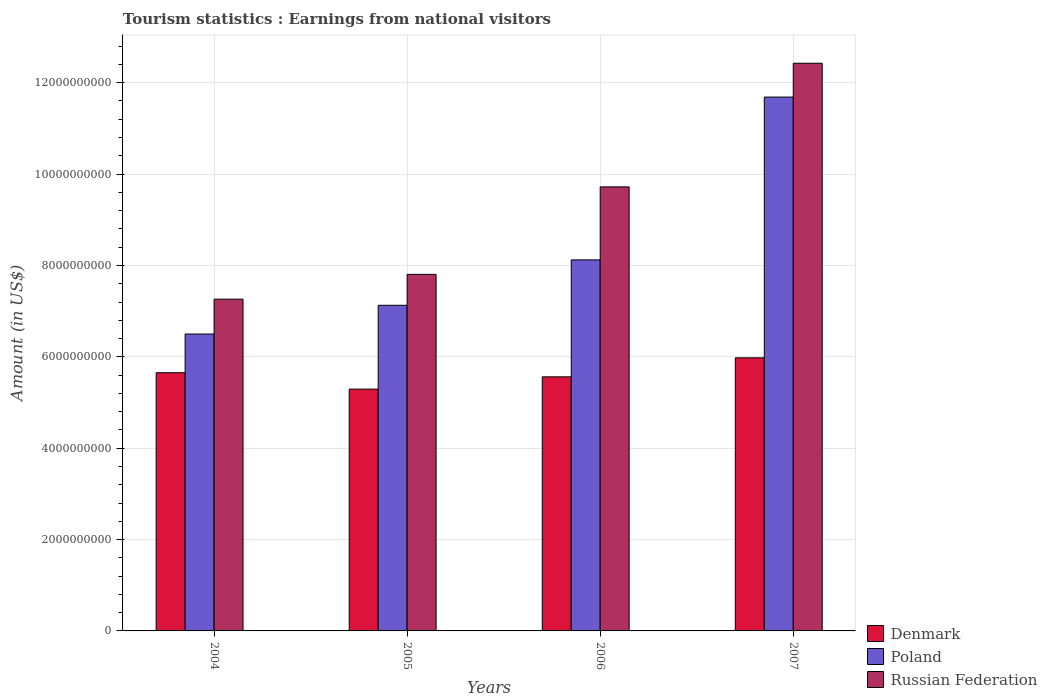How many different coloured bars are there?
Make the answer very short. 3. How many groups of bars are there?
Your answer should be compact. 4. Are the number of bars per tick equal to the number of legend labels?
Keep it short and to the point. Yes. Are the number of bars on each tick of the X-axis equal?
Give a very brief answer. Yes. How many bars are there on the 2nd tick from the right?
Offer a terse response. 3. In how many cases, is the number of bars for a given year not equal to the number of legend labels?
Make the answer very short. 0. What is the earnings from national visitors in Denmark in 2004?
Your response must be concise. 5.65e+09. Across all years, what is the maximum earnings from national visitors in Poland?
Provide a succinct answer. 1.17e+1. Across all years, what is the minimum earnings from national visitors in Poland?
Give a very brief answer. 6.50e+09. In which year was the earnings from national visitors in Denmark maximum?
Provide a succinct answer. 2007. What is the total earnings from national visitors in Denmark in the graph?
Your answer should be compact. 2.25e+1. What is the difference between the earnings from national visitors in Denmark in 2006 and that in 2007?
Give a very brief answer. -4.16e+08. What is the difference between the earnings from national visitors in Russian Federation in 2005 and the earnings from national visitors in Poland in 2004?
Your response must be concise. 1.31e+09. What is the average earnings from national visitors in Denmark per year?
Your response must be concise. 5.62e+09. In the year 2005, what is the difference between the earnings from national visitors in Poland and earnings from national visitors in Russian Federation?
Ensure brevity in your answer.  -6.77e+08. What is the ratio of the earnings from national visitors in Denmark in 2005 to that in 2006?
Give a very brief answer. 0.95. Is the earnings from national visitors in Denmark in 2006 less than that in 2007?
Ensure brevity in your answer.  Yes. Is the difference between the earnings from national visitors in Poland in 2004 and 2005 greater than the difference between the earnings from national visitors in Russian Federation in 2004 and 2005?
Provide a succinct answer. No. What is the difference between the highest and the second highest earnings from national visitors in Poland?
Ensure brevity in your answer.  3.56e+09. What is the difference between the highest and the lowest earnings from national visitors in Poland?
Your answer should be compact. 5.19e+09. What does the 2nd bar from the right in 2006 represents?
Your answer should be compact. Poland. Are all the bars in the graph horizontal?
Provide a short and direct response. No. How many years are there in the graph?
Your answer should be compact. 4. What is the difference between two consecutive major ticks on the Y-axis?
Offer a very short reply. 2.00e+09. Are the values on the major ticks of Y-axis written in scientific E-notation?
Your response must be concise. No. Does the graph contain any zero values?
Ensure brevity in your answer.  No. Does the graph contain grids?
Give a very brief answer. Yes. Where does the legend appear in the graph?
Keep it short and to the point. Bottom right. How many legend labels are there?
Offer a terse response. 3. What is the title of the graph?
Ensure brevity in your answer.  Tourism statistics : Earnings from national visitors. What is the Amount (in US$) of Denmark in 2004?
Offer a very short reply. 5.65e+09. What is the Amount (in US$) of Poland in 2004?
Your response must be concise. 6.50e+09. What is the Amount (in US$) in Russian Federation in 2004?
Provide a succinct answer. 7.26e+09. What is the Amount (in US$) of Denmark in 2005?
Your answer should be compact. 5.29e+09. What is the Amount (in US$) in Poland in 2005?
Your response must be concise. 7.13e+09. What is the Amount (in US$) in Russian Federation in 2005?
Ensure brevity in your answer.  7.80e+09. What is the Amount (in US$) in Denmark in 2006?
Provide a short and direct response. 5.56e+09. What is the Amount (in US$) in Poland in 2006?
Give a very brief answer. 8.12e+09. What is the Amount (in US$) in Russian Federation in 2006?
Make the answer very short. 9.72e+09. What is the Amount (in US$) in Denmark in 2007?
Keep it short and to the point. 5.98e+09. What is the Amount (in US$) of Poland in 2007?
Offer a very short reply. 1.17e+1. What is the Amount (in US$) of Russian Federation in 2007?
Your answer should be very brief. 1.24e+1. Across all years, what is the maximum Amount (in US$) in Denmark?
Ensure brevity in your answer.  5.98e+09. Across all years, what is the maximum Amount (in US$) of Poland?
Your response must be concise. 1.17e+1. Across all years, what is the maximum Amount (in US$) in Russian Federation?
Provide a short and direct response. 1.24e+1. Across all years, what is the minimum Amount (in US$) of Denmark?
Provide a succinct answer. 5.29e+09. Across all years, what is the minimum Amount (in US$) of Poland?
Provide a short and direct response. 6.50e+09. Across all years, what is the minimum Amount (in US$) in Russian Federation?
Give a very brief answer. 7.26e+09. What is the total Amount (in US$) of Denmark in the graph?
Keep it short and to the point. 2.25e+1. What is the total Amount (in US$) in Poland in the graph?
Make the answer very short. 3.34e+1. What is the total Amount (in US$) of Russian Federation in the graph?
Your response must be concise. 3.72e+1. What is the difference between the Amount (in US$) of Denmark in 2004 and that in 2005?
Your answer should be compact. 3.59e+08. What is the difference between the Amount (in US$) of Poland in 2004 and that in 2005?
Provide a short and direct response. -6.29e+08. What is the difference between the Amount (in US$) in Russian Federation in 2004 and that in 2005?
Offer a very short reply. -5.43e+08. What is the difference between the Amount (in US$) in Denmark in 2004 and that in 2006?
Keep it short and to the point. 9.00e+07. What is the difference between the Amount (in US$) in Poland in 2004 and that in 2006?
Keep it short and to the point. -1.62e+09. What is the difference between the Amount (in US$) in Russian Federation in 2004 and that in 2006?
Your answer should be very brief. -2.46e+09. What is the difference between the Amount (in US$) in Denmark in 2004 and that in 2007?
Give a very brief answer. -3.26e+08. What is the difference between the Amount (in US$) in Poland in 2004 and that in 2007?
Provide a short and direct response. -5.19e+09. What is the difference between the Amount (in US$) in Russian Federation in 2004 and that in 2007?
Provide a succinct answer. -5.16e+09. What is the difference between the Amount (in US$) in Denmark in 2005 and that in 2006?
Make the answer very short. -2.69e+08. What is the difference between the Amount (in US$) of Poland in 2005 and that in 2006?
Keep it short and to the point. -9.94e+08. What is the difference between the Amount (in US$) in Russian Federation in 2005 and that in 2006?
Your response must be concise. -1.92e+09. What is the difference between the Amount (in US$) in Denmark in 2005 and that in 2007?
Your answer should be compact. -6.85e+08. What is the difference between the Amount (in US$) in Poland in 2005 and that in 2007?
Your answer should be very brief. -4.56e+09. What is the difference between the Amount (in US$) of Russian Federation in 2005 and that in 2007?
Ensure brevity in your answer.  -4.62e+09. What is the difference between the Amount (in US$) of Denmark in 2006 and that in 2007?
Make the answer very short. -4.16e+08. What is the difference between the Amount (in US$) in Poland in 2006 and that in 2007?
Your answer should be very brief. -3.56e+09. What is the difference between the Amount (in US$) of Russian Federation in 2006 and that in 2007?
Your response must be concise. -2.71e+09. What is the difference between the Amount (in US$) in Denmark in 2004 and the Amount (in US$) in Poland in 2005?
Make the answer very short. -1.48e+09. What is the difference between the Amount (in US$) of Denmark in 2004 and the Amount (in US$) of Russian Federation in 2005?
Your answer should be compact. -2.15e+09. What is the difference between the Amount (in US$) in Poland in 2004 and the Amount (in US$) in Russian Federation in 2005?
Provide a short and direct response. -1.31e+09. What is the difference between the Amount (in US$) in Denmark in 2004 and the Amount (in US$) in Poland in 2006?
Your answer should be very brief. -2.47e+09. What is the difference between the Amount (in US$) in Denmark in 2004 and the Amount (in US$) in Russian Federation in 2006?
Your answer should be very brief. -4.07e+09. What is the difference between the Amount (in US$) in Poland in 2004 and the Amount (in US$) in Russian Federation in 2006?
Provide a succinct answer. -3.22e+09. What is the difference between the Amount (in US$) in Denmark in 2004 and the Amount (in US$) in Poland in 2007?
Keep it short and to the point. -6.03e+09. What is the difference between the Amount (in US$) in Denmark in 2004 and the Amount (in US$) in Russian Federation in 2007?
Your answer should be compact. -6.77e+09. What is the difference between the Amount (in US$) in Poland in 2004 and the Amount (in US$) in Russian Federation in 2007?
Keep it short and to the point. -5.93e+09. What is the difference between the Amount (in US$) in Denmark in 2005 and the Amount (in US$) in Poland in 2006?
Make the answer very short. -2.83e+09. What is the difference between the Amount (in US$) in Denmark in 2005 and the Amount (in US$) in Russian Federation in 2006?
Offer a terse response. -4.43e+09. What is the difference between the Amount (in US$) in Poland in 2005 and the Amount (in US$) in Russian Federation in 2006?
Your answer should be compact. -2.59e+09. What is the difference between the Amount (in US$) of Denmark in 2005 and the Amount (in US$) of Poland in 2007?
Your answer should be compact. -6.39e+09. What is the difference between the Amount (in US$) of Denmark in 2005 and the Amount (in US$) of Russian Federation in 2007?
Make the answer very short. -7.13e+09. What is the difference between the Amount (in US$) of Poland in 2005 and the Amount (in US$) of Russian Federation in 2007?
Provide a short and direct response. -5.30e+09. What is the difference between the Amount (in US$) of Denmark in 2006 and the Amount (in US$) of Poland in 2007?
Give a very brief answer. -6.12e+09. What is the difference between the Amount (in US$) in Denmark in 2006 and the Amount (in US$) in Russian Federation in 2007?
Your answer should be compact. -6.86e+09. What is the difference between the Amount (in US$) in Poland in 2006 and the Amount (in US$) in Russian Federation in 2007?
Your answer should be compact. -4.30e+09. What is the average Amount (in US$) in Denmark per year?
Provide a succinct answer. 5.62e+09. What is the average Amount (in US$) in Poland per year?
Offer a terse response. 8.36e+09. What is the average Amount (in US$) in Russian Federation per year?
Offer a very short reply. 9.30e+09. In the year 2004, what is the difference between the Amount (in US$) in Denmark and Amount (in US$) in Poland?
Provide a short and direct response. -8.47e+08. In the year 2004, what is the difference between the Amount (in US$) in Denmark and Amount (in US$) in Russian Federation?
Offer a very short reply. -1.61e+09. In the year 2004, what is the difference between the Amount (in US$) of Poland and Amount (in US$) of Russian Federation?
Your answer should be compact. -7.63e+08. In the year 2005, what is the difference between the Amount (in US$) in Denmark and Amount (in US$) in Poland?
Your answer should be very brief. -1.84e+09. In the year 2005, what is the difference between the Amount (in US$) of Denmark and Amount (in US$) of Russian Federation?
Give a very brief answer. -2.51e+09. In the year 2005, what is the difference between the Amount (in US$) of Poland and Amount (in US$) of Russian Federation?
Keep it short and to the point. -6.77e+08. In the year 2006, what is the difference between the Amount (in US$) of Denmark and Amount (in US$) of Poland?
Offer a terse response. -2.56e+09. In the year 2006, what is the difference between the Amount (in US$) in Denmark and Amount (in US$) in Russian Federation?
Your answer should be very brief. -4.16e+09. In the year 2006, what is the difference between the Amount (in US$) in Poland and Amount (in US$) in Russian Federation?
Your answer should be very brief. -1.60e+09. In the year 2007, what is the difference between the Amount (in US$) in Denmark and Amount (in US$) in Poland?
Your answer should be compact. -5.71e+09. In the year 2007, what is the difference between the Amount (in US$) of Denmark and Amount (in US$) of Russian Federation?
Offer a terse response. -6.45e+09. In the year 2007, what is the difference between the Amount (in US$) of Poland and Amount (in US$) of Russian Federation?
Ensure brevity in your answer.  -7.40e+08. What is the ratio of the Amount (in US$) of Denmark in 2004 to that in 2005?
Your answer should be very brief. 1.07. What is the ratio of the Amount (in US$) in Poland in 2004 to that in 2005?
Your response must be concise. 0.91. What is the ratio of the Amount (in US$) in Russian Federation in 2004 to that in 2005?
Your response must be concise. 0.93. What is the ratio of the Amount (in US$) of Denmark in 2004 to that in 2006?
Ensure brevity in your answer.  1.02. What is the ratio of the Amount (in US$) in Poland in 2004 to that in 2006?
Provide a short and direct response. 0.8. What is the ratio of the Amount (in US$) in Russian Federation in 2004 to that in 2006?
Provide a succinct answer. 0.75. What is the ratio of the Amount (in US$) of Denmark in 2004 to that in 2007?
Make the answer very short. 0.95. What is the ratio of the Amount (in US$) of Poland in 2004 to that in 2007?
Keep it short and to the point. 0.56. What is the ratio of the Amount (in US$) of Russian Federation in 2004 to that in 2007?
Your answer should be compact. 0.58. What is the ratio of the Amount (in US$) of Denmark in 2005 to that in 2006?
Provide a short and direct response. 0.95. What is the ratio of the Amount (in US$) of Poland in 2005 to that in 2006?
Offer a very short reply. 0.88. What is the ratio of the Amount (in US$) in Russian Federation in 2005 to that in 2006?
Your answer should be compact. 0.8. What is the ratio of the Amount (in US$) of Denmark in 2005 to that in 2007?
Give a very brief answer. 0.89. What is the ratio of the Amount (in US$) in Poland in 2005 to that in 2007?
Give a very brief answer. 0.61. What is the ratio of the Amount (in US$) in Russian Federation in 2005 to that in 2007?
Your response must be concise. 0.63. What is the ratio of the Amount (in US$) of Denmark in 2006 to that in 2007?
Make the answer very short. 0.93. What is the ratio of the Amount (in US$) in Poland in 2006 to that in 2007?
Provide a succinct answer. 0.69. What is the ratio of the Amount (in US$) in Russian Federation in 2006 to that in 2007?
Provide a short and direct response. 0.78. What is the difference between the highest and the second highest Amount (in US$) in Denmark?
Keep it short and to the point. 3.26e+08. What is the difference between the highest and the second highest Amount (in US$) in Poland?
Give a very brief answer. 3.56e+09. What is the difference between the highest and the second highest Amount (in US$) in Russian Federation?
Provide a short and direct response. 2.71e+09. What is the difference between the highest and the lowest Amount (in US$) of Denmark?
Your answer should be very brief. 6.85e+08. What is the difference between the highest and the lowest Amount (in US$) in Poland?
Provide a short and direct response. 5.19e+09. What is the difference between the highest and the lowest Amount (in US$) in Russian Federation?
Ensure brevity in your answer.  5.16e+09. 